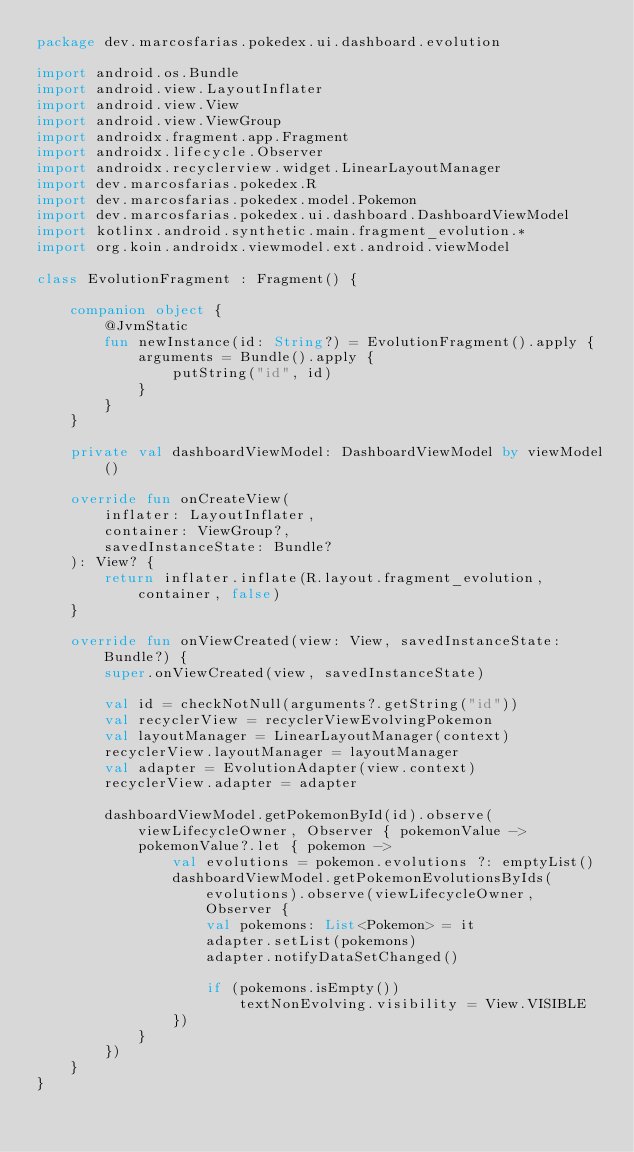Convert code to text. <code><loc_0><loc_0><loc_500><loc_500><_Kotlin_>package dev.marcosfarias.pokedex.ui.dashboard.evolution

import android.os.Bundle
import android.view.LayoutInflater
import android.view.View
import android.view.ViewGroup
import androidx.fragment.app.Fragment
import androidx.lifecycle.Observer
import androidx.recyclerview.widget.LinearLayoutManager
import dev.marcosfarias.pokedex.R
import dev.marcosfarias.pokedex.model.Pokemon
import dev.marcosfarias.pokedex.ui.dashboard.DashboardViewModel
import kotlinx.android.synthetic.main.fragment_evolution.*
import org.koin.androidx.viewmodel.ext.android.viewModel

class EvolutionFragment : Fragment() {

    companion object {
        @JvmStatic
        fun newInstance(id: String?) = EvolutionFragment().apply {
            arguments = Bundle().apply {
                putString("id", id)
            }
        }
    }

    private val dashboardViewModel: DashboardViewModel by viewModel()

    override fun onCreateView(
        inflater: LayoutInflater,
        container: ViewGroup?,
        savedInstanceState: Bundle?
    ): View? {
        return inflater.inflate(R.layout.fragment_evolution, container, false)
    }

    override fun onViewCreated(view: View, savedInstanceState: Bundle?) {
        super.onViewCreated(view, savedInstanceState)

        val id = checkNotNull(arguments?.getString("id"))
        val recyclerView = recyclerViewEvolvingPokemon
        val layoutManager = LinearLayoutManager(context)
        recyclerView.layoutManager = layoutManager
        val adapter = EvolutionAdapter(view.context)
        recyclerView.adapter = adapter

        dashboardViewModel.getPokemonById(id).observe(viewLifecycleOwner, Observer { pokemonValue ->
            pokemonValue?.let { pokemon ->
                val evolutions = pokemon.evolutions ?: emptyList()
                dashboardViewModel.getPokemonEvolutionsByIds(evolutions).observe(viewLifecycleOwner, Observer {
                    val pokemons: List<Pokemon> = it
                    adapter.setList(pokemons)
                    adapter.notifyDataSetChanged()

                    if (pokemons.isEmpty())
                        textNonEvolving.visibility = View.VISIBLE
                })
            }
        })
    }
}
</code> 